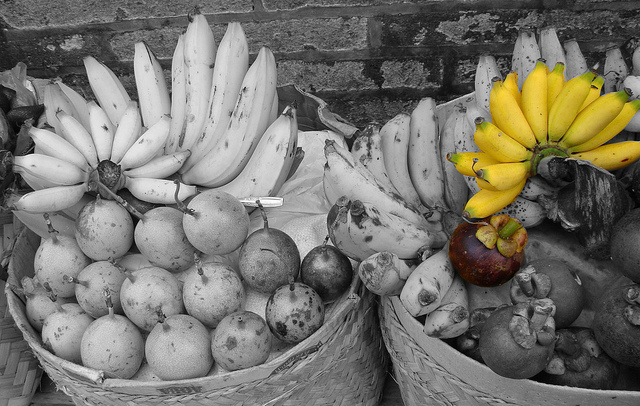Please provide a short description for this region: [0.69, 0.27, 1.0, 0.52]. A bunch of yellow bananas. 